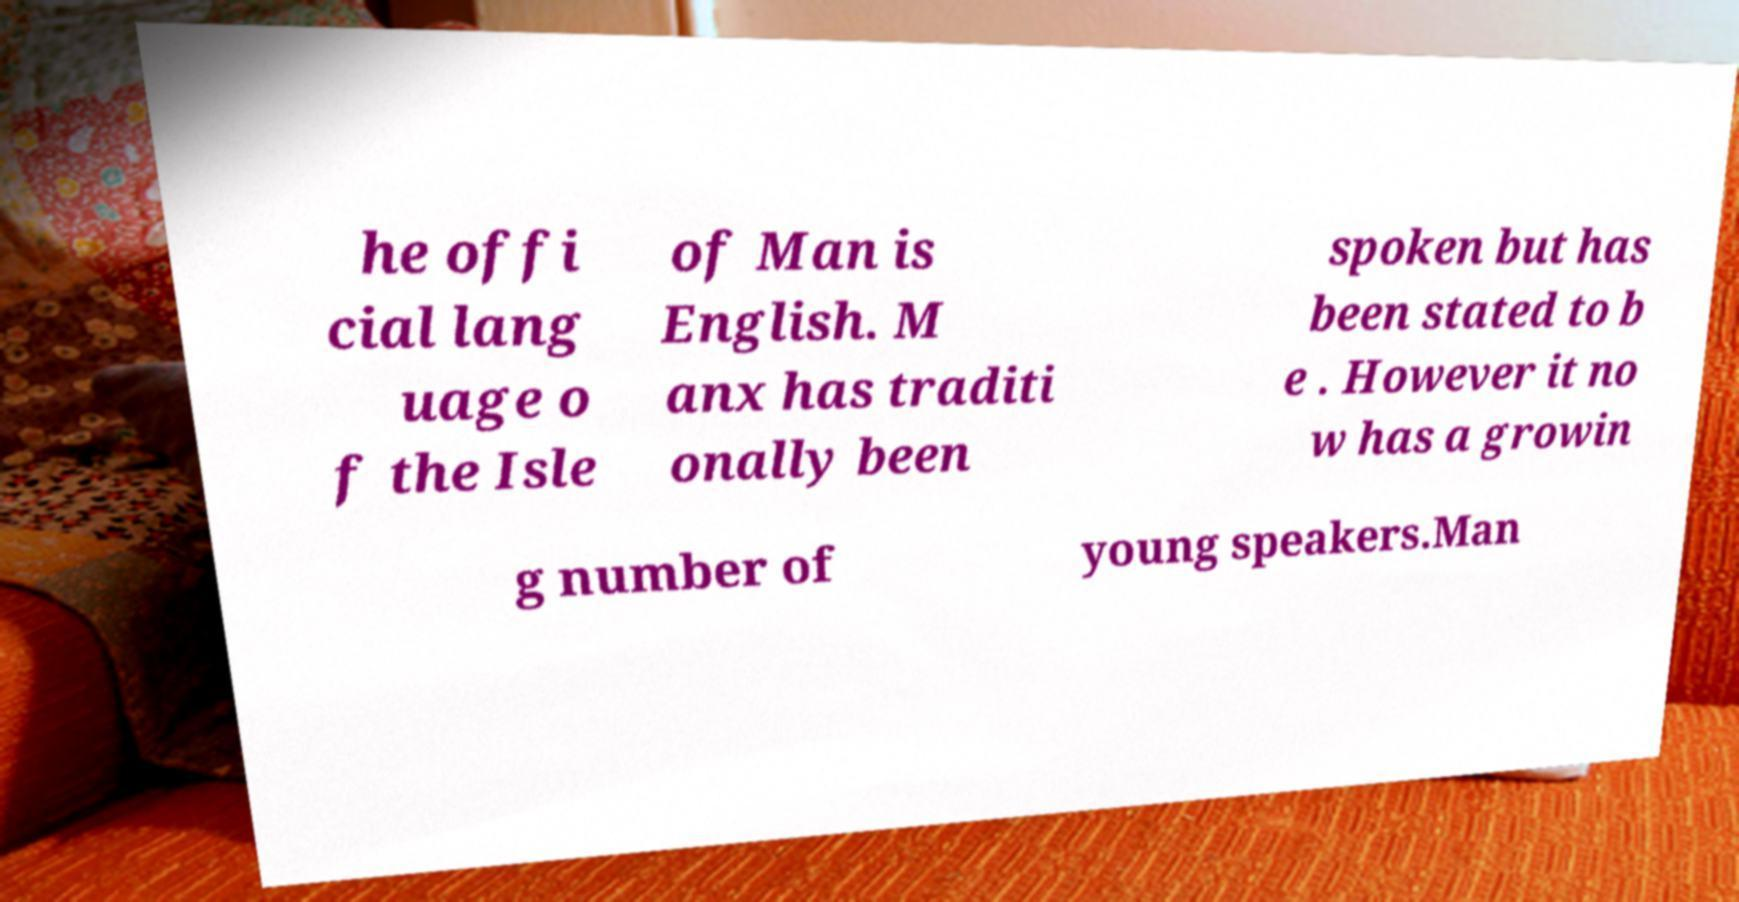Could you assist in decoding the text presented in this image and type it out clearly? he offi cial lang uage o f the Isle of Man is English. M anx has traditi onally been spoken but has been stated to b e . However it no w has a growin g number of young speakers.Man 